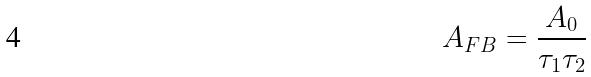<formula> <loc_0><loc_0><loc_500><loc_500>A _ { F B } = \frac { A _ { 0 } } { \tau _ { 1 } \tau _ { 2 } }</formula> 